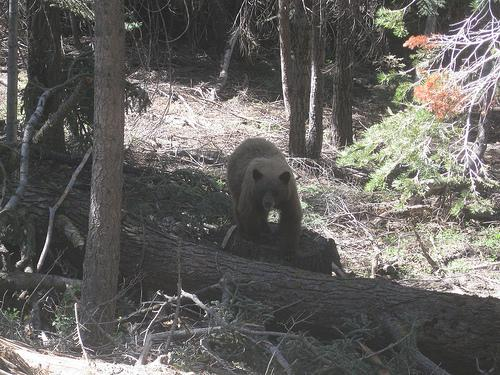Can you identify any trees in the image and if so, what are their types? There are pine tree trunks and tree branches with green and reddish leaves in the forest. What is the primary focus of the image and what is its action? The primary focus of the image is a brown bear walking in the woods. Analyze the sentiment or mood of the image. The image evokes a sense of wilderness and tranquility, as it captures a bear in its natural habitat, exploring the picturesque forest. Mention any elements on the ground in the image. There is a fallen tree trunk, various sticks, and some grass on the ground in the woods. Provide a brief summary of the forest scene. A large, light brown bear is walking through a forest filled with pine trees, fallen tree trunks, sticks, and leaves. Discuss the state of the fallen tree trunk and its surroundings. The fallen tree trunk is brown and has bark with striation marks. It is surrounded by sticks, dirt, and possibly some dead branches. Describe the distinctive features of the bear's ears and nose. The bear has pointy ears with a black right ear and a black left ear, and its nose is black as well. What is the bear doing and what is its appearance? The bear is walking on all fours in the woods, has light brown fur, pointy ears, and a long snout with a black nose. Count the number of ears, legs, and noses on the bear. The bear has two ears, four legs, and one nose. Using descriptive language, describe the leaves in the image. The image features green leaves on tree branches, as well as reddish leaves that seem to be dying or changing color. Do you see any streams or rivers in the forest? No, it's not mentioned in the image. Is the bear's fur white and fluffy? The image consistently describes the bear's fur as brown, and there is no information about the texture of the fur being fluffy. What is the position of the bear in the picture, amidst the forest setting? On all fours, standing on a tree stump Create a visual composition with elements from the image. A digitally designed poster of a serene forest, with sunlight streaming through the trees, illuminating a majestic brown bear standing on a moss-covered tree stump, surrounded by fallen trunks and vibrantly colored leaves. Narrate a creative and engaging description of the image. A majestic, light brown bear traverses a serene forest, where sunbeams penetrate the dense canopy and illuminate fallen pine trunks and vibrant, multicolored leaves. The bear stands on a tree stump, surveying its surroundings with curiosity, as reddish leaves and green foliage frame the picturesque scene. List the parts of the bear that are visible in the image. Head, ears, nose, snout, and front legs Explain the role played by sunlight in the scene. Sunlight breaking through trees highlights the bear and the surroundings, creating a calming atmosphere. Which elements in the scene indicate that parts of the leaves on the tree have died? Reddish leaves and dead branches on the ground Determine the focal point of the image. The brown bear standing on the tree stump Describe the emotions expressed by the bear in the image. The bear does not show a specific emotion. Describe the condition of the fallen tree trunks present in the image. Old, brown, with some bark and striation marks What type of tree trunks are present in the image? Pine tree trunks Identify the main components of the scene captured in the image. Brown bear, fallen tree trunk, leaves on tree branches, sunlight, and forest setting Explain the current event occurring in the scene. A brown bear is walking in a forest, stepping on a tree stump among fallen trees, various sticks, and colorful leaves. Is there a squirrel perched on the pine tree trunk? There is no mention of any squirrel in the image, nor any indication that an animal is perched on the pine tree trunk. Can you find the blue bird sitting on the fallen tree trunk? There is no mention of a blue bird in the image. The image includes a fallen tree trunk, but there is no reference to any birds. Identify the prominent colors of leaves on the tree branches. Green and reddish-orange Choose the correct description of the bear from the following options: a) Sitting on a tree branch, b) Standing on tree stump, c) Swimming in water, d) Climbing a mountain b) Standing on tree stump Are the leaves of the tree all yellow? The image mentions green leaves on a tree branch and reddish leaves on another tree branch, but there is no mention of yellow leaves. What is the color of the bear's fur? Light brown Describe the bear's ears and their color in the image. The bear has small, pointy ears with black fur. Is the bear climbing on a tree? There is no indication in the image that the bear is climbing a tree. The bear is described as being on the ground, on all fours, or walking in the woods. Which animal is depicted in the image? Brown bear Describe the snout of the bear in the image. The bear's snout is long with a black nose. Describe the ground below the bear in the image. The ground is covered with sticks, dirt, grass, and fallen leaves. 